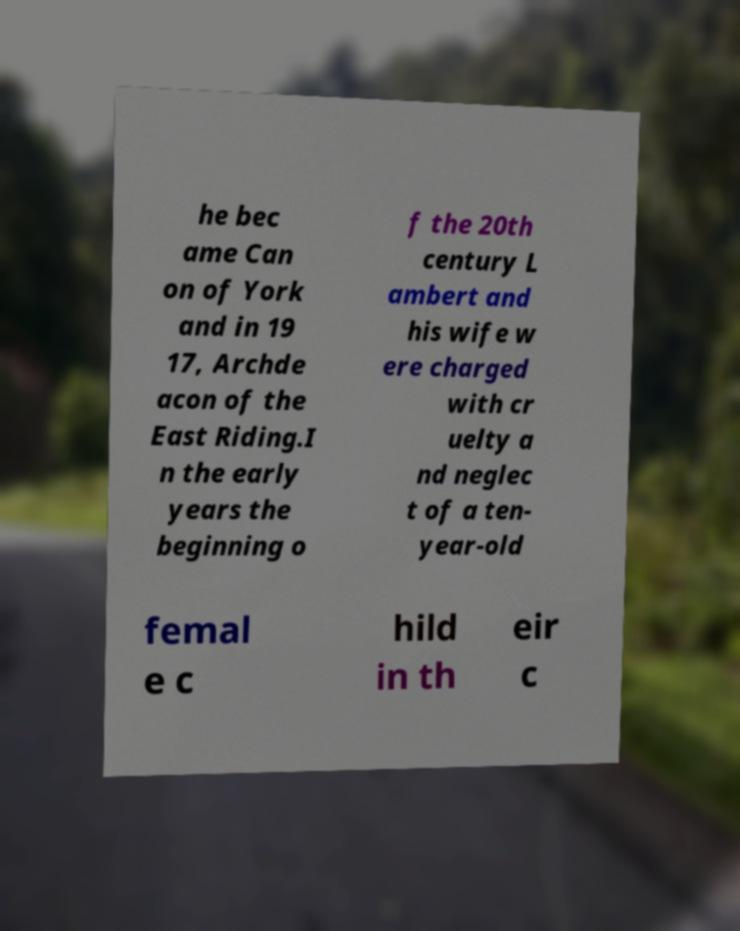Please identify and transcribe the text found in this image. he bec ame Can on of York and in 19 17, Archde acon of the East Riding.I n the early years the beginning o f the 20th century L ambert and his wife w ere charged with cr uelty a nd neglec t of a ten- year-old femal e c hild in th eir c 